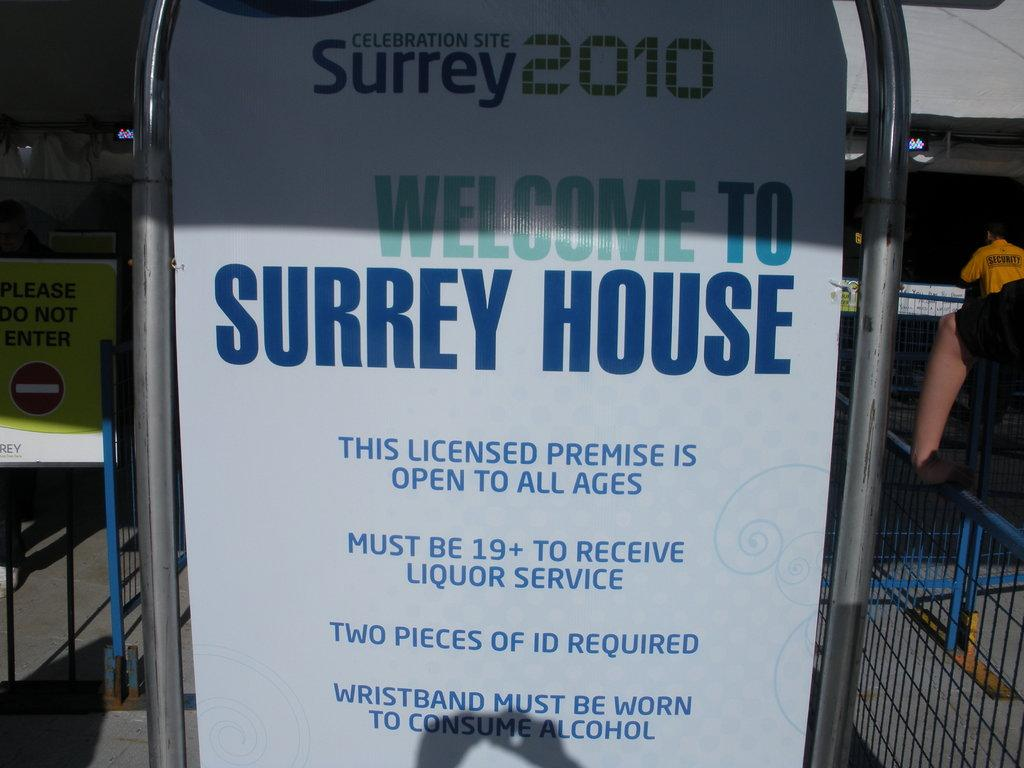What is written on the boards in the image? There are boards with text in the image, but the specific text cannot be determined from the facts provided. Who are the two persons on the right side of the image? The facts do not provide information about the identity of the two persons on the right side of the image. What can be seen in the bottom right of the image? There are grills in the bottom right of the image. What color is the silverware used by the persons in the image? There is no mention of silverware in the image, so we cannot determine its color. How far can the persons stretch their arms in the image? The facts do not provide information about the physical actions or positions of the persons in the image, so we cannot determine how far they can stretch their arms. 